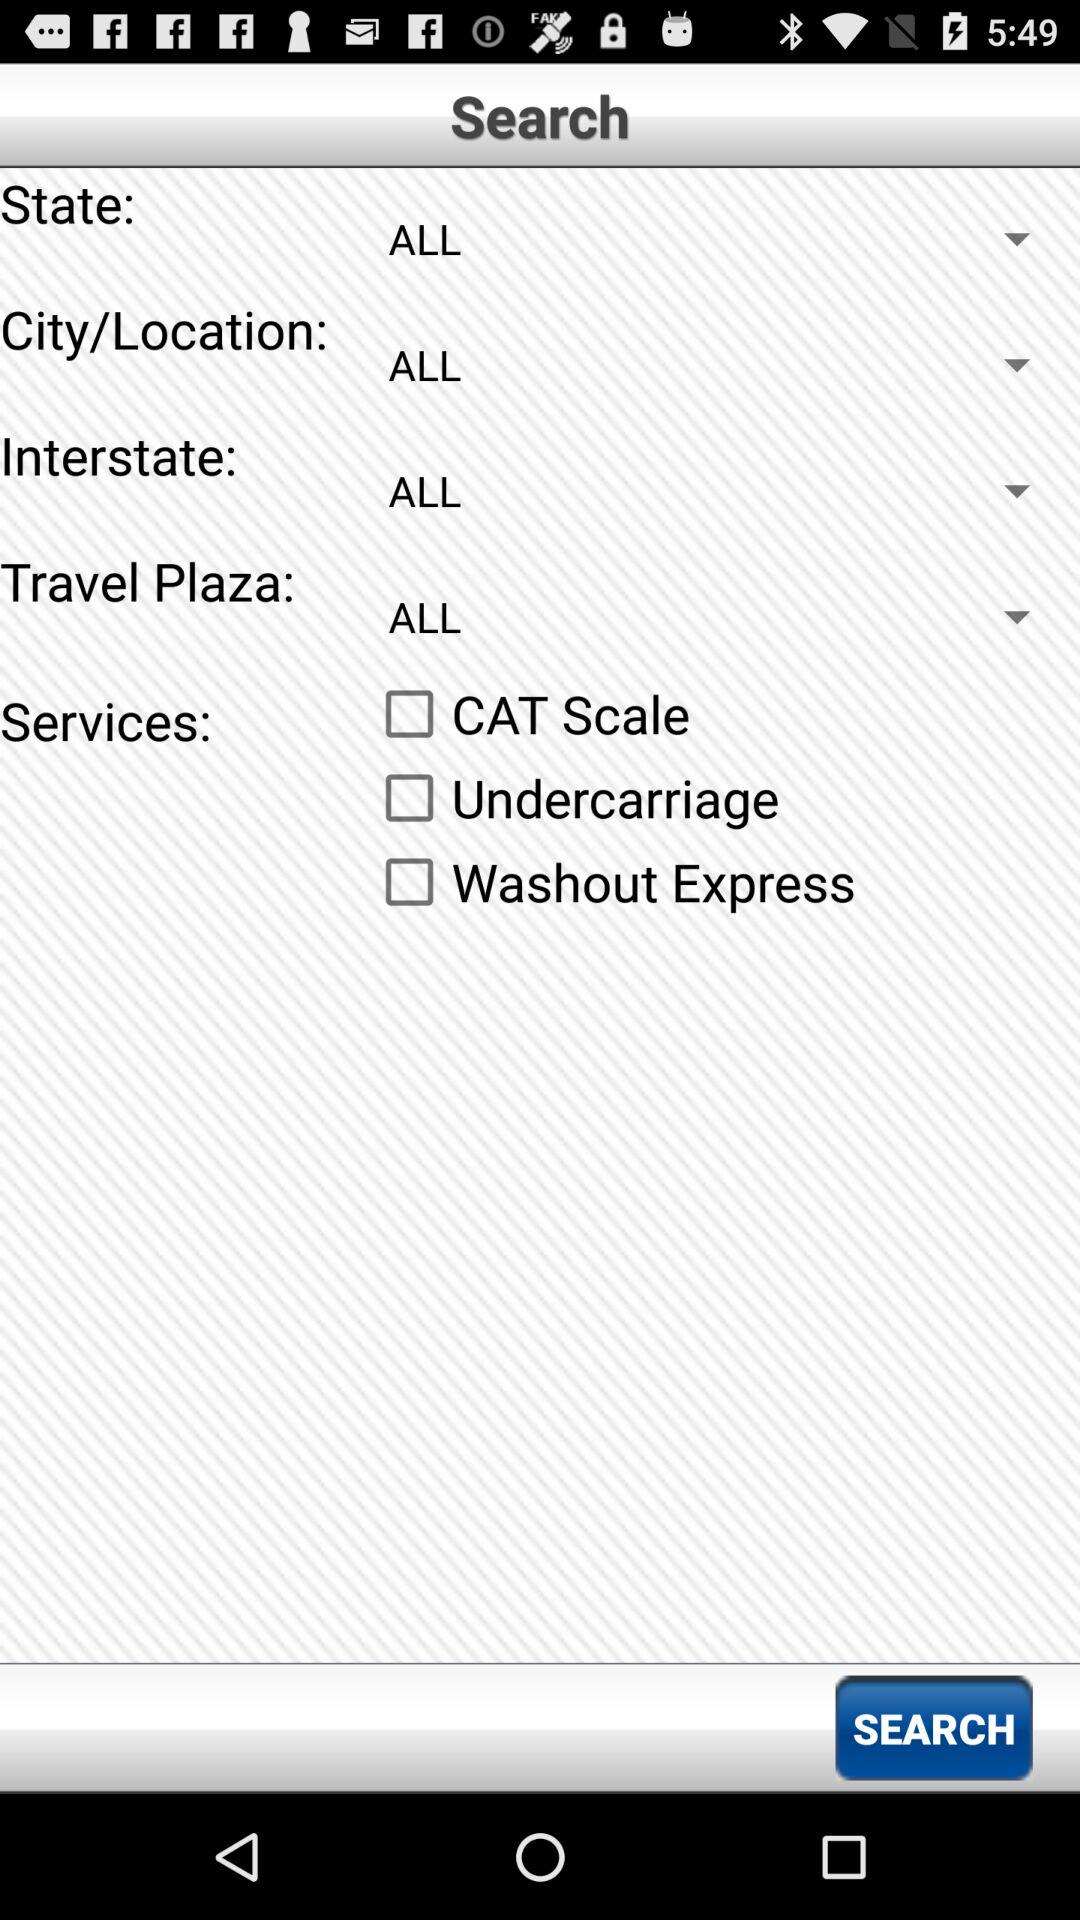What are the options for services? The options are "CAT Scale", "Undercarriage" and "Washout Express". 